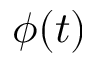<formula> <loc_0><loc_0><loc_500><loc_500>\phi ( t )</formula> 